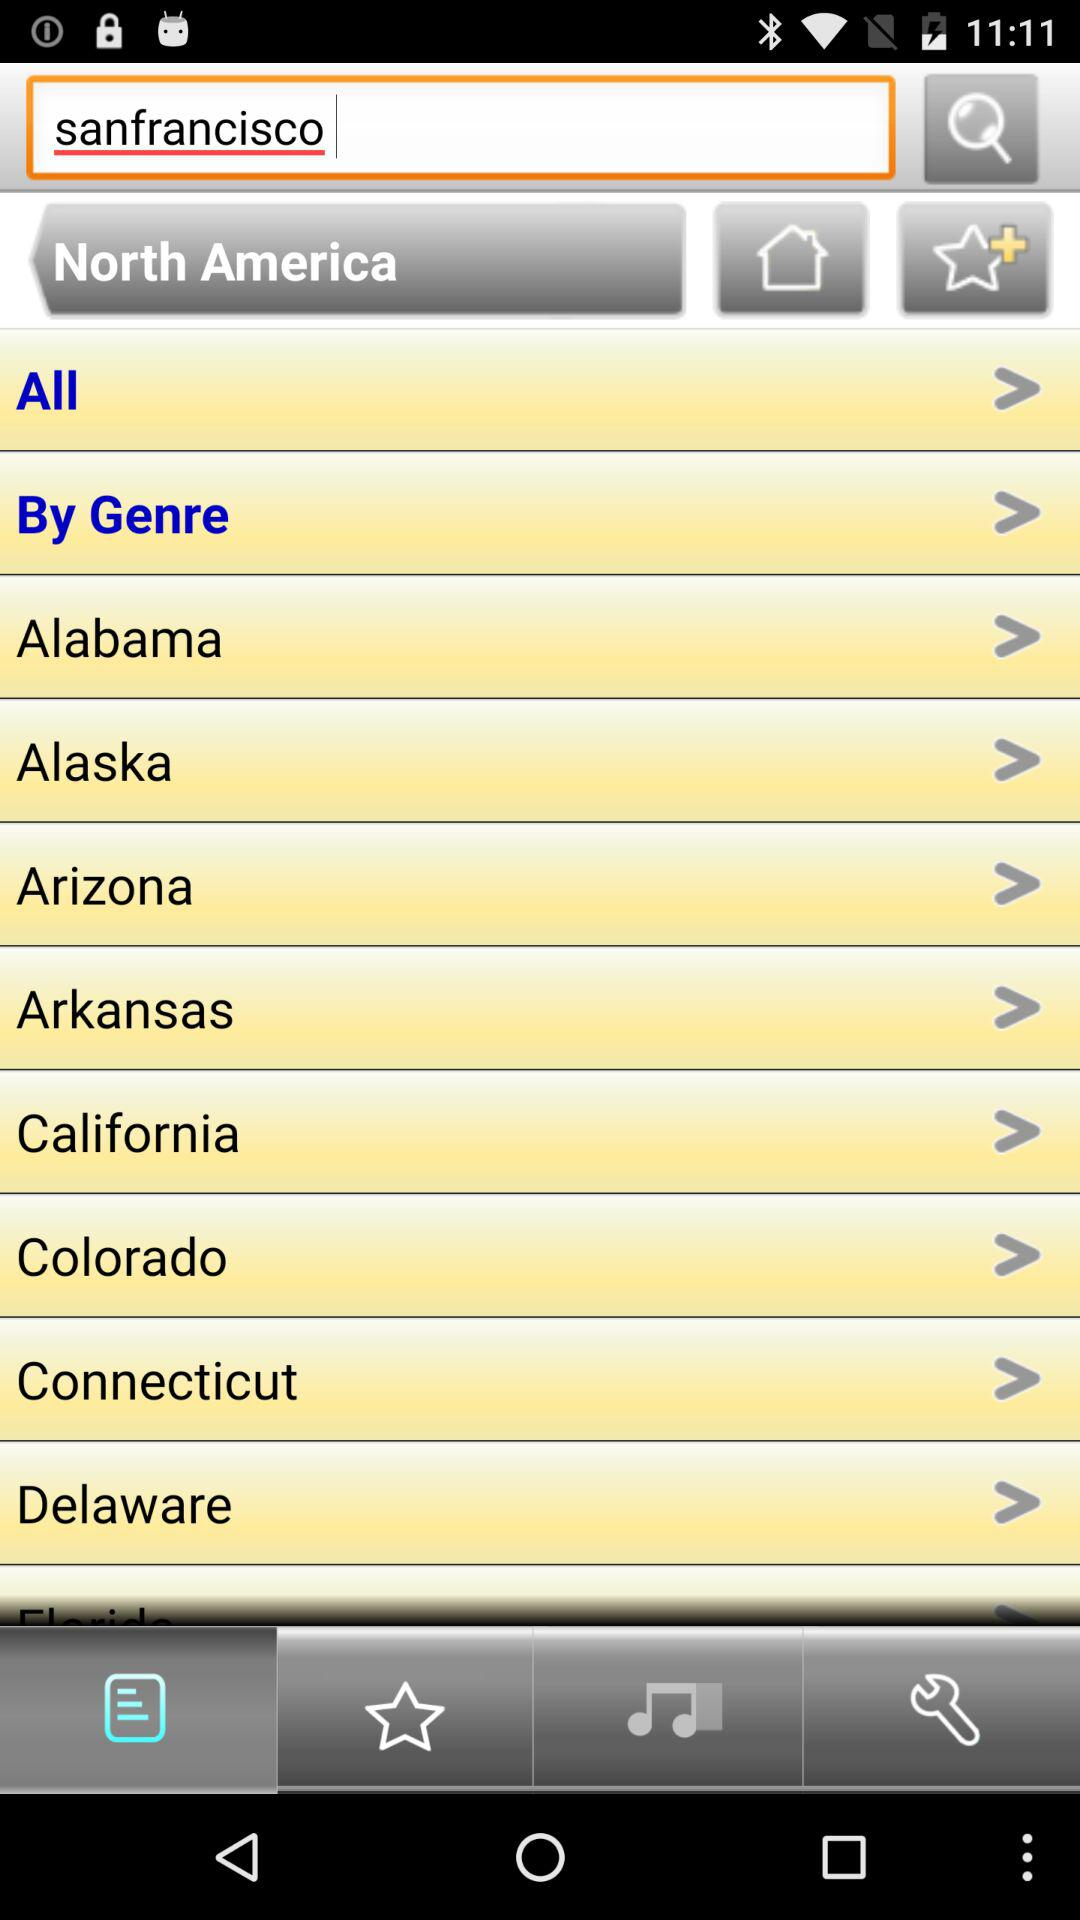What is the city in the search box? The city is San Francisco. 